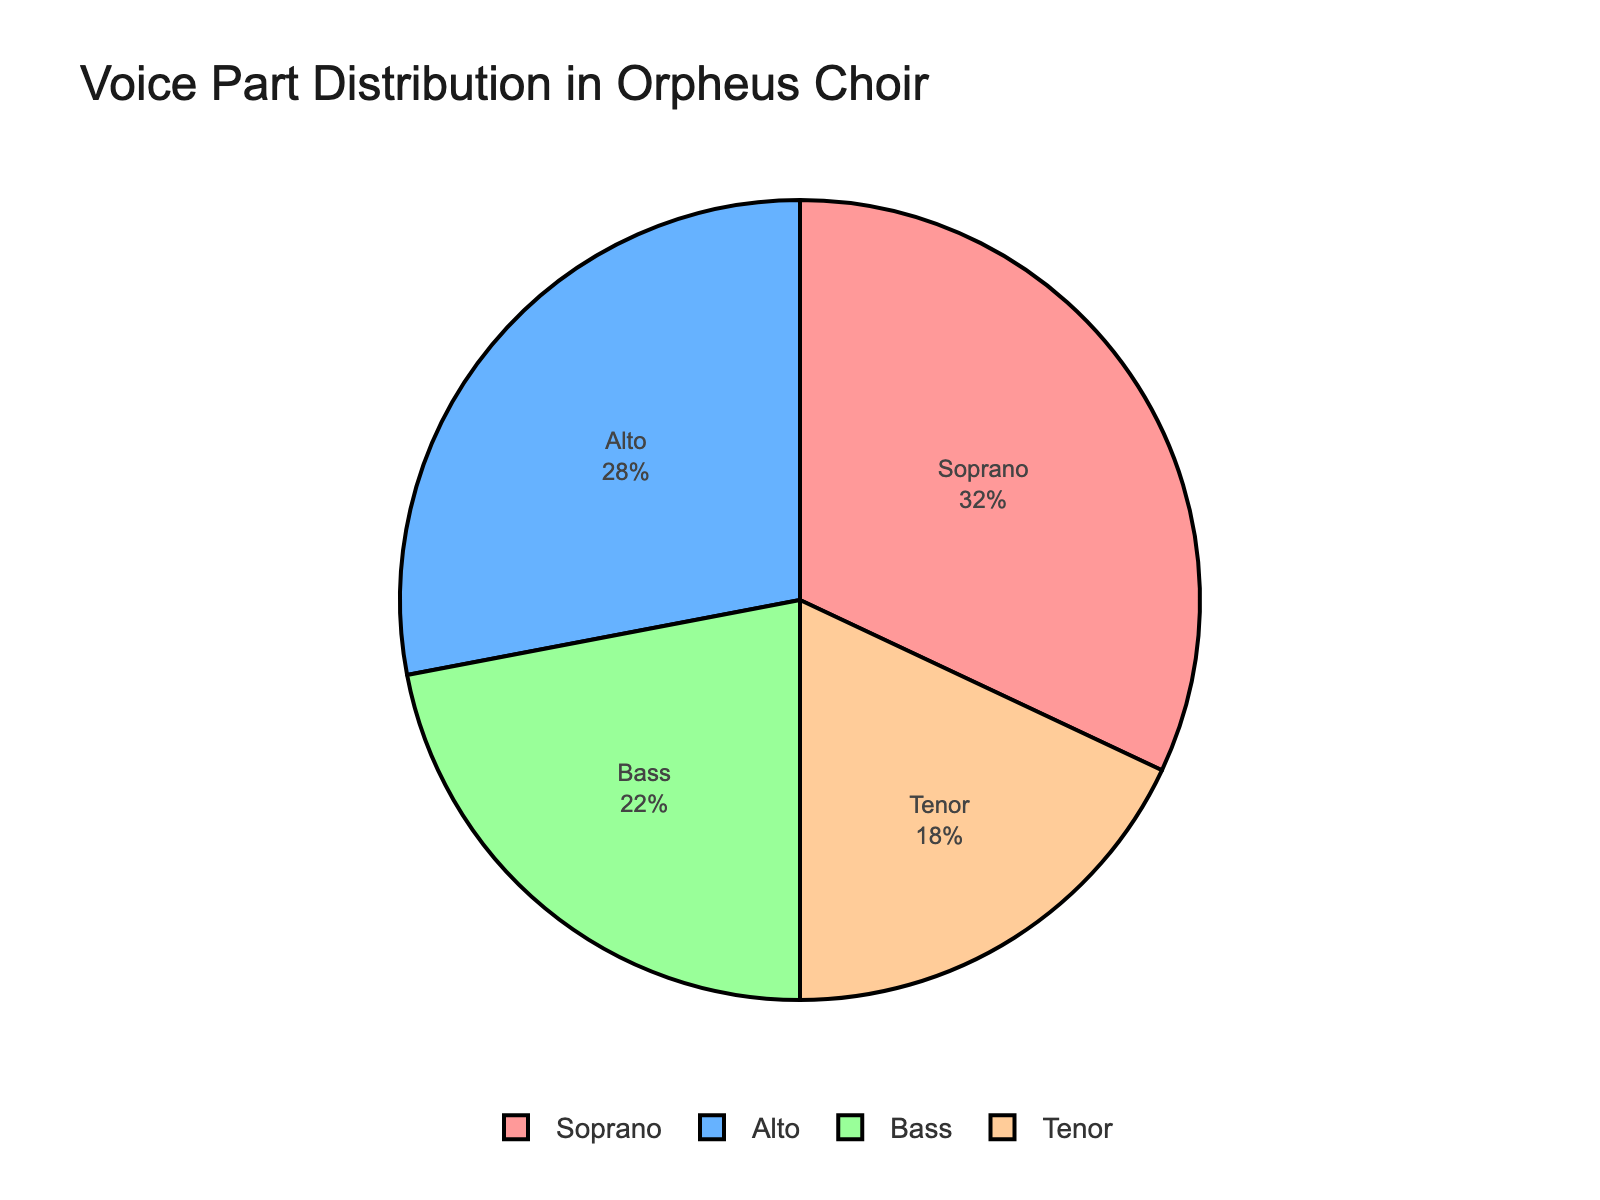What percentage of the Orpheus Choir are sopranos? Look at the pie chart section labeled "Soprano" and note its percentage value.
Answer: 32% Which voice part has the smallest representation in the choir? Compare the percentage values for each voice part and identify the smallest one. Tenor has 18%, which is the smallest.
Answer: Tenor What is the combined percentage of altos and basses in the choir? Add the percentage values for altos and basses. That is 28% + 22% = 50%.
Answer: 50% Which voice parts have a higher percentage than tenors? Look at the percentage values for each voice part and compare them with tenors' 18%. Sopranos (32%), altos (28%), and basses (22%) all have higher percentages.
Answer: Soprano, Alto, Bass How many percentage points higher is the percentage of sopranos compared to tenors? Subtract the percentage of tenors from the percentage of sopranos. That is, 32% - 18% = 14%.
Answer: 14% If the choir were to recruit more members to balance the voice parts equally, how much more percentage should be added to the tenor section? The target percentage for each voice part to be equal is 25%. The current tenor percentage is 18%. 25% - 18% = 7%.
Answer: 7% What percentage more are basses compared to tenors? The percentage of basses is 22% and tenors is 18%. Calculate the percentage difference. (22% - 18%) / 18% * 100 = 22.22%.
Answer: 22.22% What is the average percentage of all four voice parts in the choir? Sum the percentages of all voice parts and divide by 4. That is (32% + 28% + 18% + 22%) / 4 = 25%.
Answer: 25% 